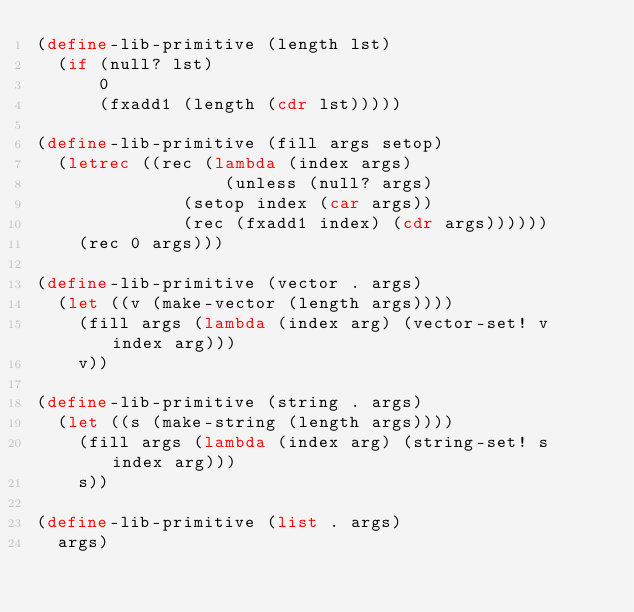Convert code to text. <code><loc_0><loc_0><loc_500><loc_500><_Scheme_>(define-lib-primitive (length lst)
  (if (null? lst)
      0
      (fxadd1 (length (cdr lst)))))

(define-lib-primitive (fill args setop)
  (letrec ((rec (lambda (index args)
                  (unless (null? args)
			  (setop index (car args))
			  (rec (fxadd1 index) (cdr args))))))
    (rec 0 args)))

(define-lib-primitive (vector . args)
  (let ((v (make-vector (length args))))
    (fill args (lambda (index arg) (vector-set! v index arg)))
    v))

(define-lib-primitive (string . args)
  (let ((s (make-string (length args))))
    (fill args (lambda (index arg) (string-set! s index arg)))
    s))

(define-lib-primitive (list . args)
  args)
</code> 